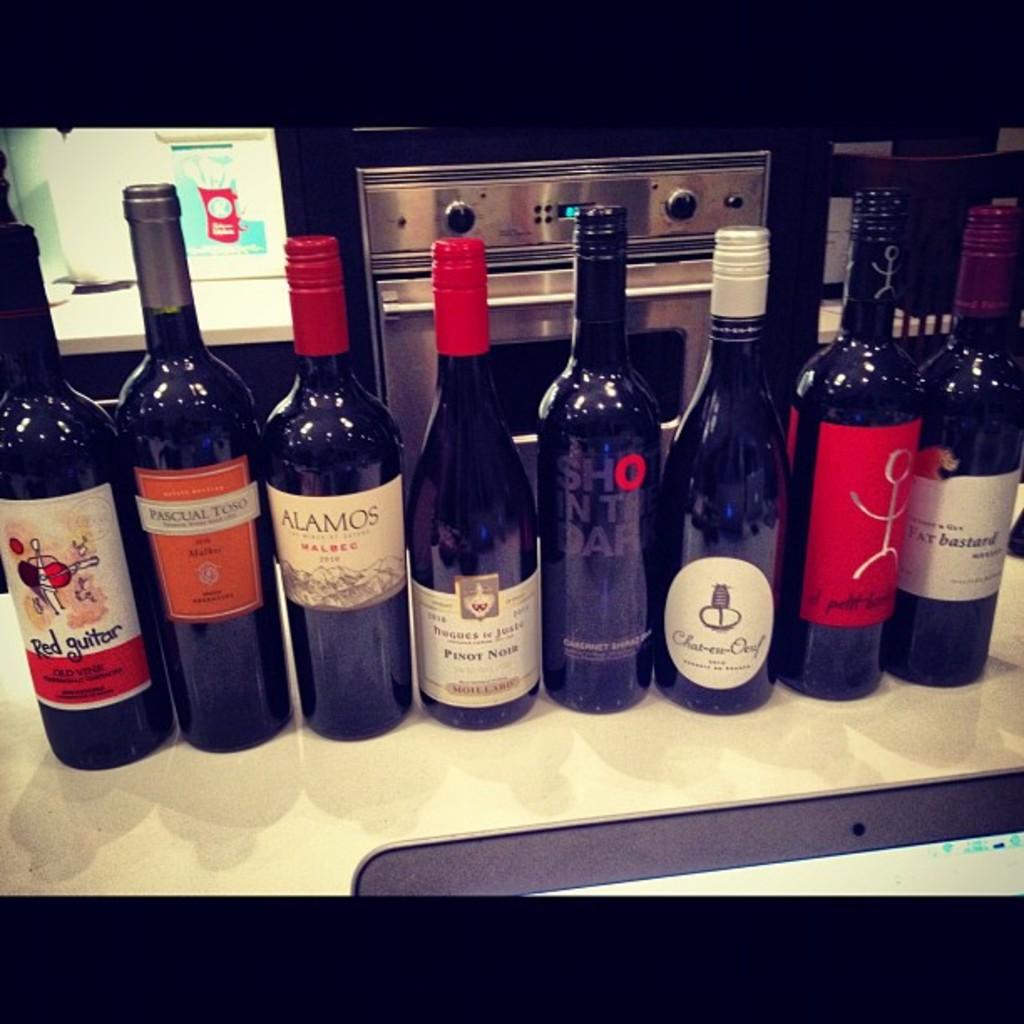What wine is the one on the right?
Your response must be concise. Fat bastard. What is the brand of the wine on the third bottle from the left?
Give a very brief answer. Alamos. 